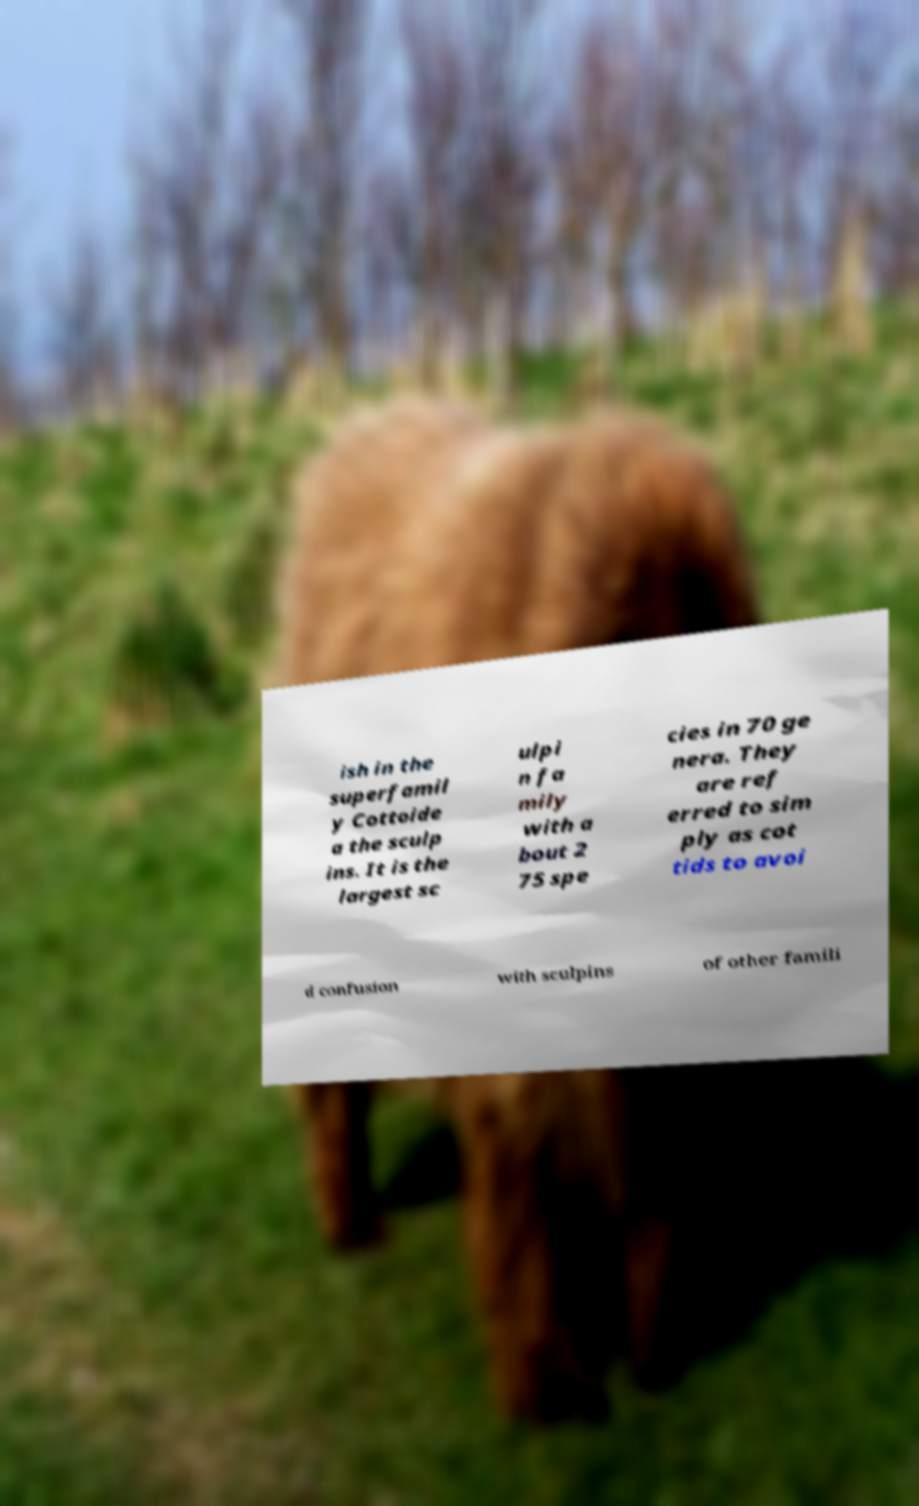Can you read and provide the text displayed in the image?This photo seems to have some interesting text. Can you extract and type it out for me? ish in the superfamil y Cottoide a the sculp ins. It is the largest sc ulpi n fa mily with a bout 2 75 spe cies in 70 ge nera. They are ref erred to sim ply as cot tids to avoi d confusion with sculpins of other famili 